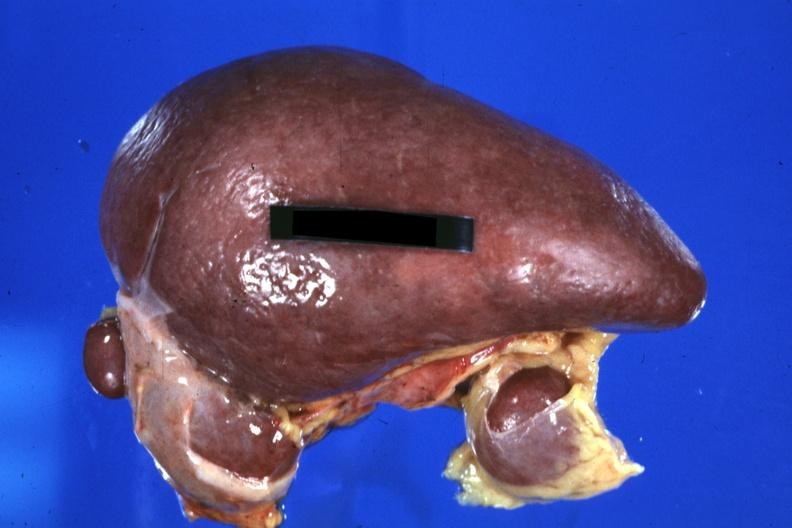what left isomerism and complex congenital heart disease?
Answer the question using a single word or phrase. Spleen with three accessories 32yobf 